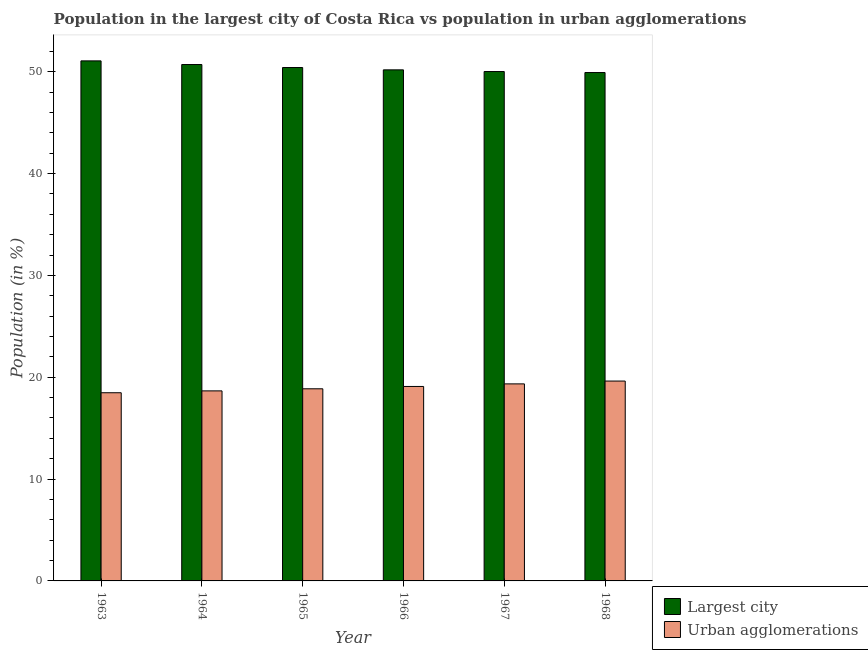How many different coloured bars are there?
Your answer should be very brief. 2. Are the number of bars per tick equal to the number of legend labels?
Provide a short and direct response. Yes. Are the number of bars on each tick of the X-axis equal?
Provide a short and direct response. Yes. How many bars are there on the 2nd tick from the left?
Your answer should be very brief. 2. What is the label of the 3rd group of bars from the left?
Provide a succinct answer. 1965. What is the population in the largest city in 1968?
Ensure brevity in your answer.  49.93. Across all years, what is the maximum population in the largest city?
Give a very brief answer. 51.07. Across all years, what is the minimum population in urban agglomerations?
Keep it short and to the point. 18.48. In which year was the population in urban agglomerations maximum?
Offer a very short reply. 1968. In which year was the population in the largest city minimum?
Offer a very short reply. 1968. What is the total population in the largest city in the graph?
Provide a succinct answer. 302.34. What is the difference between the population in urban agglomerations in 1964 and that in 1967?
Make the answer very short. -0.69. What is the difference between the population in the largest city in 1968 and the population in urban agglomerations in 1966?
Provide a succinct answer. -0.26. What is the average population in urban agglomerations per year?
Ensure brevity in your answer.  19.01. In the year 1968, what is the difference between the population in the largest city and population in urban agglomerations?
Keep it short and to the point. 0. What is the ratio of the population in urban agglomerations in 1965 to that in 1966?
Give a very brief answer. 0.99. Is the difference between the population in the largest city in 1965 and 1966 greater than the difference between the population in urban agglomerations in 1965 and 1966?
Your answer should be very brief. No. What is the difference between the highest and the second highest population in urban agglomerations?
Provide a succinct answer. 0.28. What is the difference between the highest and the lowest population in urban agglomerations?
Provide a short and direct response. 1.15. In how many years, is the population in urban agglomerations greater than the average population in urban agglomerations taken over all years?
Provide a succinct answer. 3. What does the 1st bar from the left in 1963 represents?
Ensure brevity in your answer.  Largest city. What does the 2nd bar from the right in 1964 represents?
Make the answer very short. Largest city. How many bars are there?
Provide a short and direct response. 12. How many years are there in the graph?
Your answer should be very brief. 6. Does the graph contain any zero values?
Offer a terse response. No. Does the graph contain grids?
Ensure brevity in your answer.  No. How are the legend labels stacked?
Make the answer very short. Vertical. What is the title of the graph?
Your response must be concise. Population in the largest city of Costa Rica vs population in urban agglomerations. Does "Fixed telephone" appear as one of the legend labels in the graph?
Offer a terse response. No. What is the label or title of the X-axis?
Make the answer very short. Year. What is the Population (in %) of Largest city in 1963?
Give a very brief answer. 51.07. What is the Population (in %) of Urban agglomerations in 1963?
Ensure brevity in your answer.  18.48. What is the Population (in %) of Largest city in 1964?
Provide a short and direct response. 50.71. What is the Population (in %) of Urban agglomerations in 1964?
Your response must be concise. 18.66. What is the Population (in %) in Largest city in 1965?
Provide a succinct answer. 50.42. What is the Population (in %) in Urban agglomerations in 1965?
Provide a short and direct response. 18.87. What is the Population (in %) in Largest city in 1966?
Offer a terse response. 50.19. What is the Population (in %) in Urban agglomerations in 1966?
Give a very brief answer. 19.1. What is the Population (in %) of Largest city in 1967?
Offer a very short reply. 50.02. What is the Population (in %) in Urban agglomerations in 1967?
Your response must be concise. 19.35. What is the Population (in %) in Largest city in 1968?
Give a very brief answer. 49.93. What is the Population (in %) in Urban agglomerations in 1968?
Keep it short and to the point. 19.63. Across all years, what is the maximum Population (in %) in Largest city?
Your answer should be very brief. 51.07. Across all years, what is the maximum Population (in %) in Urban agglomerations?
Your answer should be very brief. 19.63. Across all years, what is the minimum Population (in %) in Largest city?
Provide a short and direct response. 49.93. Across all years, what is the minimum Population (in %) of Urban agglomerations?
Your answer should be compact. 18.48. What is the total Population (in %) in Largest city in the graph?
Your answer should be very brief. 302.34. What is the total Population (in %) of Urban agglomerations in the graph?
Your answer should be very brief. 114.09. What is the difference between the Population (in %) in Largest city in 1963 and that in 1964?
Offer a terse response. 0.36. What is the difference between the Population (in %) of Urban agglomerations in 1963 and that in 1964?
Make the answer very short. -0.18. What is the difference between the Population (in %) in Largest city in 1963 and that in 1965?
Make the answer very short. 0.65. What is the difference between the Population (in %) of Urban agglomerations in 1963 and that in 1965?
Your answer should be very brief. -0.39. What is the difference between the Population (in %) in Largest city in 1963 and that in 1966?
Offer a terse response. 0.88. What is the difference between the Population (in %) in Urban agglomerations in 1963 and that in 1966?
Provide a succinct answer. -0.62. What is the difference between the Population (in %) in Largest city in 1963 and that in 1967?
Keep it short and to the point. 1.05. What is the difference between the Population (in %) of Urban agglomerations in 1963 and that in 1967?
Give a very brief answer. -0.87. What is the difference between the Population (in %) of Largest city in 1963 and that in 1968?
Provide a succinct answer. 1.14. What is the difference between the Population (in %) in Urban agglomerations in 1963 and that in 1968?
Offer a terse response. -1.15. What is the difference between the Population (in %) in Largest city in 1964 and that in 1965?
Provide a succinct answer. 0.3. What is the difference between the Population (in %) in Urban agglomerations in 1964 and that in 1965?
Offer a terse response. -0.21. What is the difference between the Population (in %) in Largest city in 1964 and that in 1966?
Keep it short and to the point. 0.52. What is the difference between the Population (in %) in Urban agglomerations in 1964 and that in 1966?
Provide a short and direct response. -0.43. What is the difference between the Population (in %) of Largest city in 1964 and that in 1967?
Provide a short and direct response. 0.69. What is the difference between the Population (in %) in Urban agglomerations in 1964 and that in 1967?
Make the answer very short. -0.69. What is the difference between the Population (in %) of Largest city in 1964 and that in 1968?
Your answer should be very brief. 0.79. What is the difference between the Population (in %) of Urban agglomerations in 1964 and that in 1968?
Make the answer very short. -0.97. What is the difference between the Population (in %) of Largest city in 1965 and that in 1966?
Your answer should be compact. 0.23. What is the difference between the Population (in %) of Urban agglomerations in 1965 and that in 1966?
Your answer should be very brief. -0.23. What is the difference between the Population (in %) of Largest city in 1965 and that in 1967?
Your answer should be very brief. 0.39. What is the difference between the Population (in %) of Urban agglomerations in 1965 and that in 1967?
Your answer should be compact. -0.48. What is the difference between the Population (in %) of Largest city in 1965 and that in 1968?
Make the answer very short. 0.49. What is the difference between the Population (in %) of Urban agglomerations in 1965 and that in 1968?
Give a very brief answer. -0.76. What is the difference between the Population (in %) of Largest city in 1966 and that in 1967?
Make the answer very short. 0.17. What is the difference between the Population (in %) of Urban agglomerations in 1966 and that in 1967?
Your answer should be compact. -0.25. What is the difference between the Population (in %) in Largest city in 1966 and that in 1968?
Make the answer very short. 0.26. What is the difference between the Population (in %) in Urban agglomerations in 1966 and that in 1968?
Ensure brevity in your answer.  -0.53. What is the difference between the Population (in %) in Largest city in 1967 and that in 1968?
Provide a succinct answer. 0.1. What is the difference between the Population (in %) of Urban agglomerations in 1967 and that in 1968?
Keep it short and to the point. -0.28. What is the difference between the Population (in %) in Largest city in 1963 and the Population (in %) in Urban agglomerations in 1964?
Your answer should be very brief. 32.41. What is the difference between the Population (in %) of Largest city in 1963 and the Population (in %) of Urban agglomerations in 1965?
Your answer should be compact. 32.2. What is the difference between the Population (in %) of Largest city in 1963 and the Population (in %) of Urban agglomerations in 1966?
Your response must be concise. 31.97. What is the difference between the Population (in %) in Largest city in 1963 and the Population (in %) in Urban agglomerations in 1967?
Your answer should be very brief. 31.72. What is the difference between the Population (in %) in Largest city in 1963 and the Population (in %) in Urban agglomerations in 1968?
Keep it short and to the point. 31.44. What is the difference between the Population (in %) of Largest city in 1964 and the Population (in %) of Urban agglomerations in 1965?
Keep it short and to the point. 31.84. What is the difference between the Population (in %) of Largest city in 1964 and the Population (in %) of Urban agglomerations in 1966?
Your response must be concise. 31.62. What is the difference between the Population (in %) of Largest city in 1964 and the Population (in %) of Urban agglomerations in 1967?
Your answer should be compact. 31.36. What is the difference between the Population (in %) in Largest city in 1964 and the Population (in %) in Urban agglomerations in 1968?
Keep it short and to the point. 31.08. What is the difference between the Population (in %) in Largest city in 1965 and the Population (in %) in Urban agglomerations in 1966?
Give a very brief answer. 31.32. What is the difference between the Population (in %) of Largest city in 1965 and the Population (in %) of Urban agglomerations in 1967?
Give a very brief answer. 31.07. What is the difference between the Population (in %) in Largest city in 1965 and the Population (in %) in Urban agglomerations in 1968?
Ensure brevity in your answer.  30.79. What is the difference between the Population (in %) in Largest city in 1966 and the Population (in %) in Urban agglomerations in 1967?
Offer a terse response. 30.84. What is the difference between the Population (in %) of Largest city in 1966 and the Population (in %) of Urban agglomerations in 1968?
Keep it short and to the point. 30.56. What is the difference between the Population (in %) of Largest city in 1967 and the Population (in %) of Urban agglomerations in 1968?
Your answer should be compact. 30.4. What is the average Population (in %) in Largest city per year?
Your answer should be very brief. 50.39. What is the average Population (in %) of Urban agglomerations per year?
Offer a very short reply. 19.01. In the year 1963, what is the difference between the Population (in %) in Largest city and Population (in %) in Urban agglomerations?
Keep it short and to the point. 32.59. In the year 1964, what is the difference between the Population (in %) in Largest city and Population (in %) in Urban agglomerations?
Your answer should be compact. 32.05. In the year 1965, what is the difference between the Population (in %) of Largest city and Population (in %) of Urban agglomerations?
Your response must be concise. 31.55. In the year 1966, what is the difference between the Population (in %) of Largest city and Population (in %) of Urban agglomerations?
Your answer should be compact. 31.09. In the year 1967, what is the difference between the Population (in %) in Largest city and Population (in %) in Urban agglomerations?
Your answer should be compact. 30.67. In the year 1968, what is the difference between the Population (in %) of Largest city and Population (in %) of Urban agglomerations?
Your answer should be very brief. 30.3. What is the ratio of the Population (in %) of Largest city in 1963 to that in 1964?
Your response must be concise. 1.01. What is the ratio of the Population (in %) in Urban agglomerations in 1963 to that in 1964?
Keep it short and to the point. 0.99. What is the ratio of the Population (in %) in Urban agglomerations in 1963 to that in 1965?
Your answer should be very brief. 0.98. What is the ratio of the Population (in %) of Largest city in 1963 to that in 1966?
Provide a succinct answer. 1.02. What is the ratio of the Population (in %) of Largest city in 1963 to that in 1967?
Provide a succinct answer. 1.02. What is the ratio of the Population (in %) of Urban agglomerations in 1963 to that in 1967?
Give a very brief answer. 0.96. What is the ratio of the Population (in %) in Largest city in 1963 to that in 1968?
Provide a succinct answer. 1.02. What is the ratio of the Population (in %) of Urban agglomerations in 1963 to that in 1968?
Offer a very short reply. 0.94. What is the ratio of the Population (in %) in Largest city in 1964 to that in 1965?
Make the answer very short. 1.01. What is the ratio of the Population (in %) of Largest city in 1964 to that in 1966?
Ensure brevity in your answer.  1.01. What is the ratio of the Population (in %) of Urban agglomerations in 1964 to that in 1966?
Give a very brief answer. 0.98. What is the ratio of the Population (in %) of Largest city in 1964 to that in 1967?
Make the answer very short. 1.01. What is the ratio of the Population (in %) in Urban agglomerations in 1964 to that in 1967?
Your response must be concise. 0.96. What is the ratio of the Population (in %) of Largest city in 1964 to that in 1968?
Make the answer very short. 1.02. What is the ratio of the Population (in %) in Urban agglomerations in 1964 to that in 1968?
Your response must be concise. 0.95. What is the ratio of the Population (in %) of Largest city in 1965 to that in 1966?
Offer a terse response. 1. What is the ratio of the Population (in %) in Largest city in 1965 to that in 1967?
Offer a very short reply. 1.01. What is the ratio of the Population (in %) in Urban agglomerations in 1965 to that in 1967?
Provide a short and direct response. 0.98. What is the ratio of the Population (in %) in Largest city in 1965 to that in 1968?
Provide a succinct answer. 1.01. What is the ratio of the Population (in %) of Urban agglomerations in 1965 to that in 1968?
Offer a terse response. 0.96. What is the ratio of the Population (in %) of Largest city in 1966 to that in 1967?
Offer a very short reply. 1. What is the ratio of the Population (in %) in Urban agglomerations in 1966 to that in 1967?
Your answer should be compact. 0.99. What is the ratio of the Population (in %) of Urban agglomerations in 1966 to that in 1968?
Your answer should be very brief. 0.97. What is the ratio of the Population (in %) of Urban agglomerations in 1967 to that in 1968?
Keep it short and to the point. 0.99. What is the difference between the highest and the second highest Population (in %) of Largest city?
Provide a short and direct response. 0.36. What is the difference between the highest and the second highest Population (in %) of Urban agglomerations?
Offer a terse response. 0.28. What is the difference between the highest and the lowest Population (in %) in Largest city?
Make the answer very short. 1.14. What is the difference between the highest and the lowest Population (in %) in Urban agglomerations?
Make the answer very short. 1.15. 